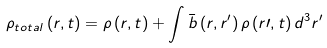<formula> <loc_0><loc_0><loc_500><loc_500>\rho _ { t o t a l } \left ( r , t \right ) = \rho \left ( r , t \right ) + \int \bar { b } \left ( r , r ^ { \prime } \right ) \rho \left ( r { \prime } , t \right ) d ^ { 3 } r ^ { \prime }</formula> 